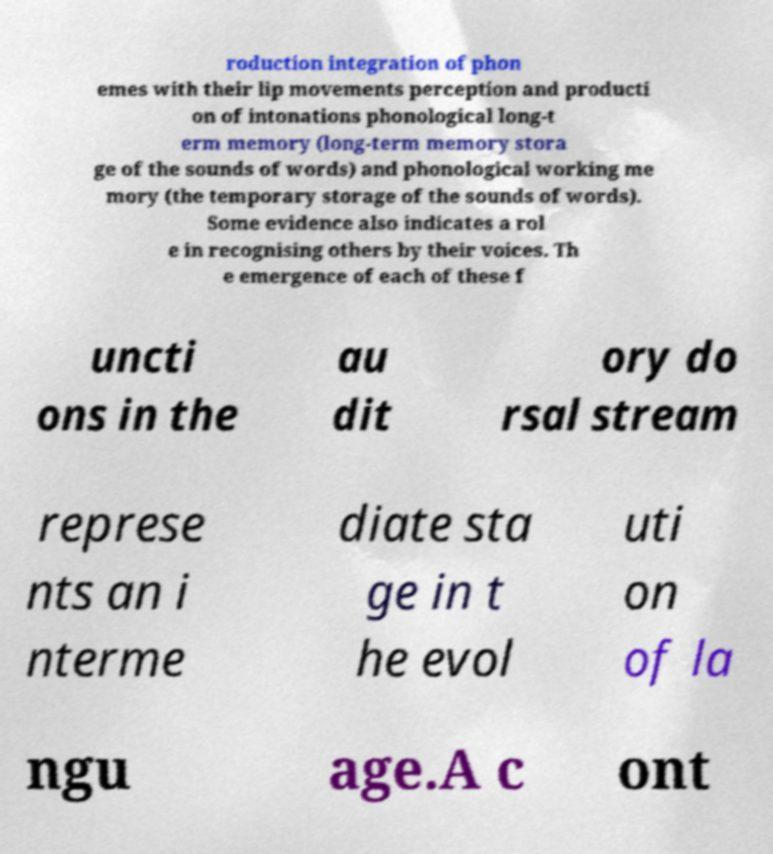There's text embedded in this image that I need extracted. Can you transcribe it verbatim? roduction integration of phon emes with their lip movements perception and producti on of intonations phonological long-t erm memory (long-term memory stora ge of the sounds of words) and phonological working me mory (the temporary storage of the sounds of words). Some evidence also indicates a rol e in recognising others by their voices. Th e emergence of each of these f uncti ons in the au dit ory do rsal stream represe nts an i nterme diate sta ge in t he evol uti on of la ngu age.A c ont 